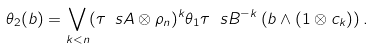Convert formula to latex. <formula><loc_0><loc_0><loc_500><loc_500>\theta _ { 2 } ( b ) = \bigvee _ { k < n } ( \tau _ { \ } s A \otimes \rho _ { n } ) ^ { k } \theta _ { 1 } \tau _ { \ } s B ^ { - k } \left ( b \wedge ( 1 \otimes c _ { k } ) \right ) .</formula> 